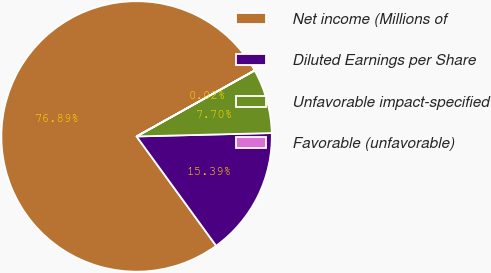Convert chart to OTSL. <chart><loc_0><loc_0><loc_500><loc_500><pie_chart><fcel>Net income (Millions of<fcel>Diluted Earnings per Share<fcel>Unfavorable impact-specified<fcel>Favorable (unfavorable)<nl><fcel>76.89%<fcel>15.39%<fcel>7.7%<fcel>0.02%<nl></chart> 